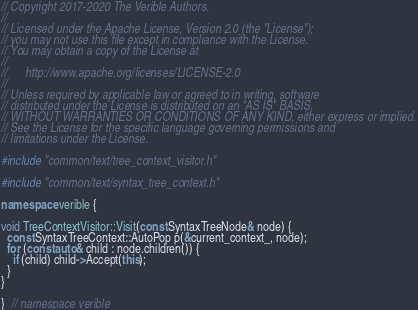Convert code to text. <code><loc_0><loc_0><loc_500><loc_500><_C++_>// Copyright 2017-2020 The Verible Authors.
//
// Licensed under the Apache License, Version 2.0 (the "License");
// you may not use this file except in compliance with the License.
// You may obtain a copy of the License at
//
//      http://www.apache.org/licenses/LICENSE-2.0
//
// Unless required by applicable law or agreed to in writing, software
// distributed under the License is distributed on an "AS IS" BASIS,
// WITHOUT WARRANTIES OR CONDITIONS OF ANY KIND, either express or implied.
// See the License for the specific language governing permissions and
// limitations under the License.

#include "common/text/tree_context_visitor.h"

#include "common/text/syntax_tree_context.h"

namespace verible {

void TreeContextVisitor::Visit(const SyntaxTreeNode& node) {
  const SyntaxTreeContext::AutoPop p(&current_context_, node);
  for (const auto& child : node.children()) {
    if (child) child->Accept(this);
  }
}

}  // namespace verible
</code> 